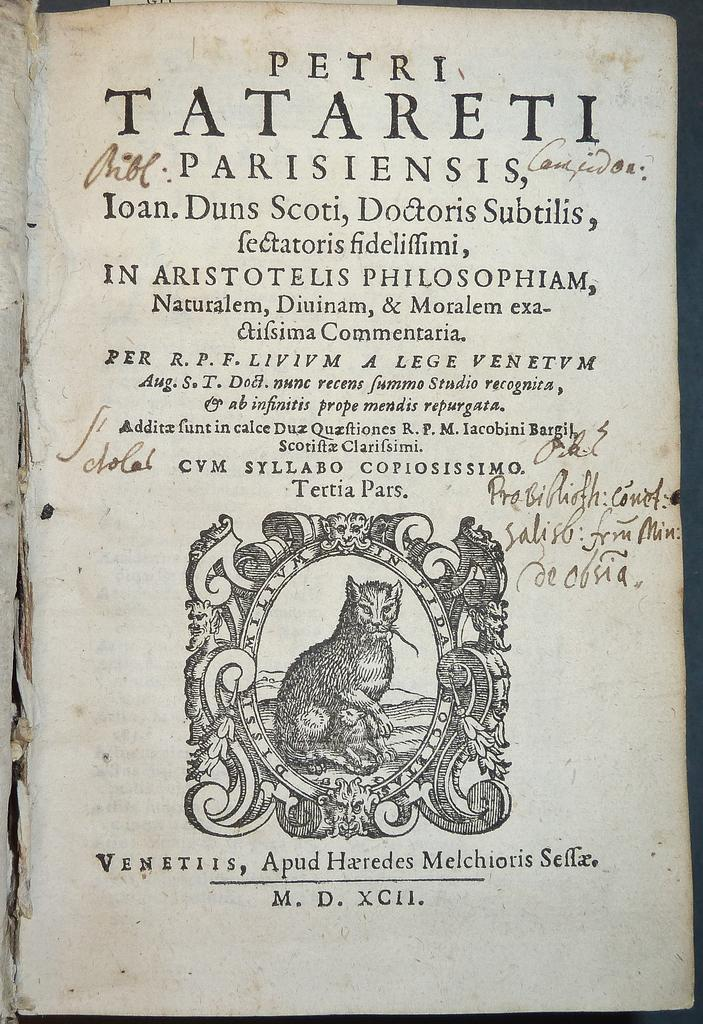What is present in the image that has a picture on it? There is a paper in the image that has a picture of a cat. What else can be found on the paper besides the picture? There is text on the paper. What type of underwear is the cat wearing in the image? There is no cat or underwear present in the image; it only features a paper with a picture of a cat and text. 